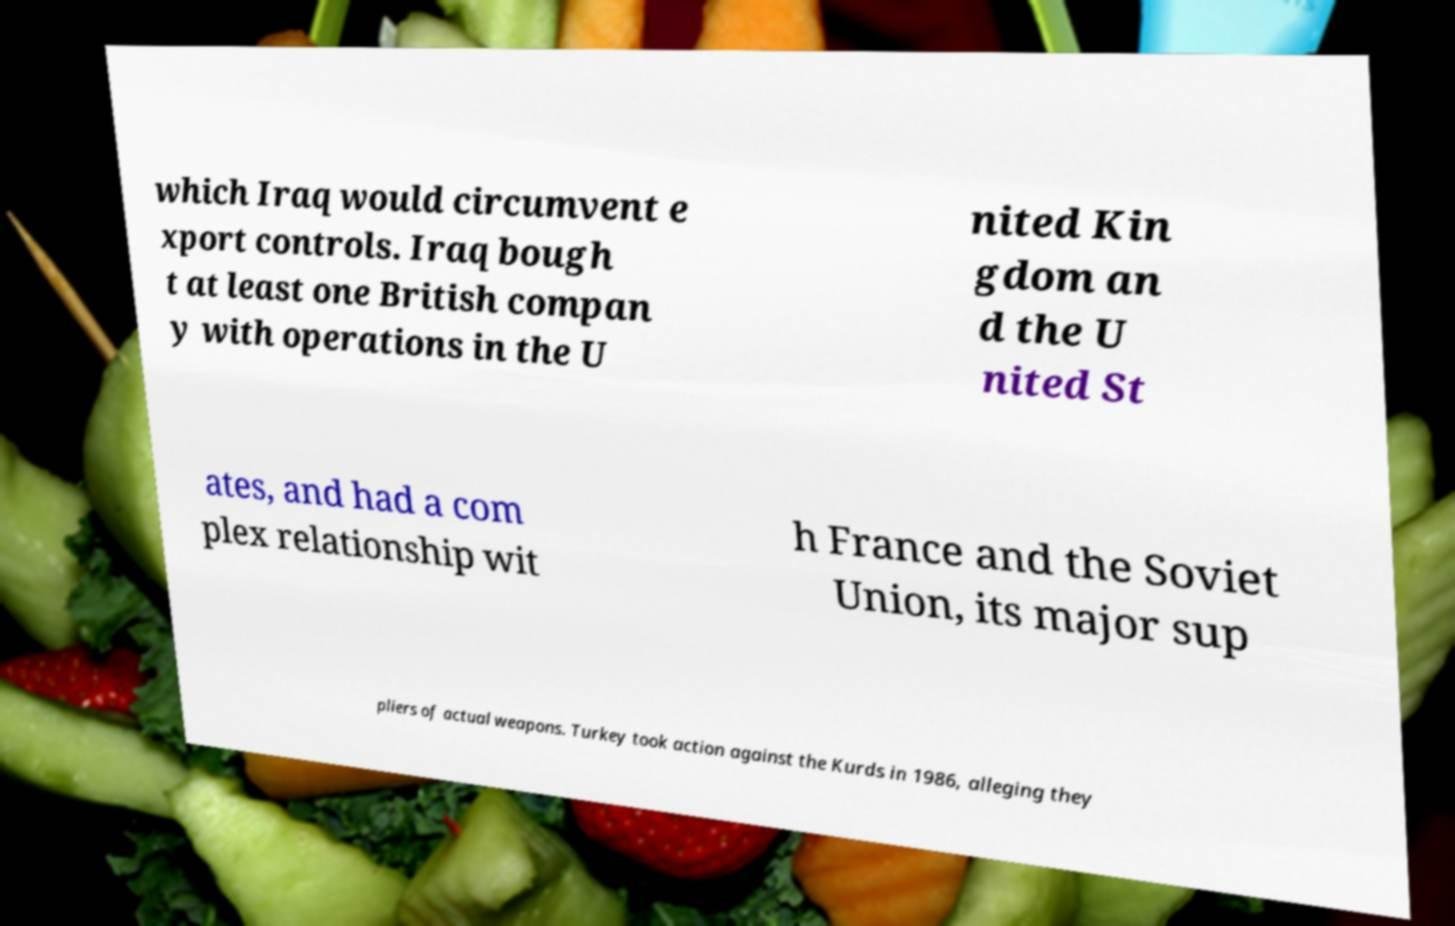Could you extract and type out the text from this image? which Iraq would circumvent e xport controls. Iraq bough t at least one British compan y with operations in the U nited Kin gdom an d the U nited St ates, and had a com plex relationship wit h France and the Soviet Union, its major sup pliers of actual weapons. Turkey took action against the Kurds in 1986, alleging they 